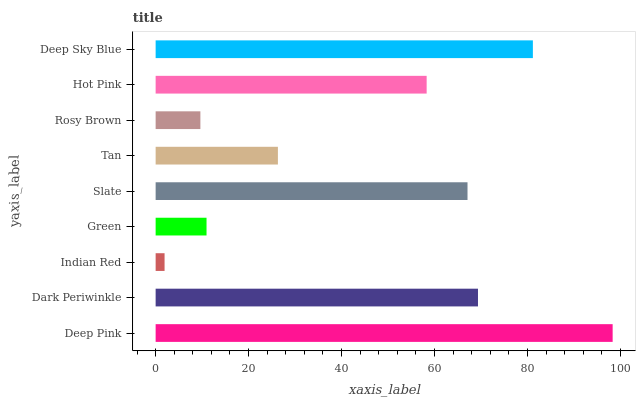Is Indian Red the minimum?
Answer yes or no. Yes. Is Deep Pink the maximum?
Answer yes or no. Yes. Is Dark Periwinkle the minimum?
Answer yes or no. No. Is Dark Periwinkle the maximum?
Answer yes or no. No. Is Deep Pink greater than Dark Periwinkle?
Answer yes or no. Yes. Is Dark Periwinkle less than Deep Pink?
Answer yes or no. Yes. Is Dark Periwinkle greater than Deep Pink?
Answer yes or no. No. Is Deep Pink less than Dark Periwinkle?
Answer yes or no. No. Is Hot Pink the high median?
Answer yes or no. Yes. Is Hot Pink the low median?
Answer yes or no. Yes. Is Indian Red the high median?
Answer yes or no. No. Is Indian Red the low median?
Answer yes or no. No. 